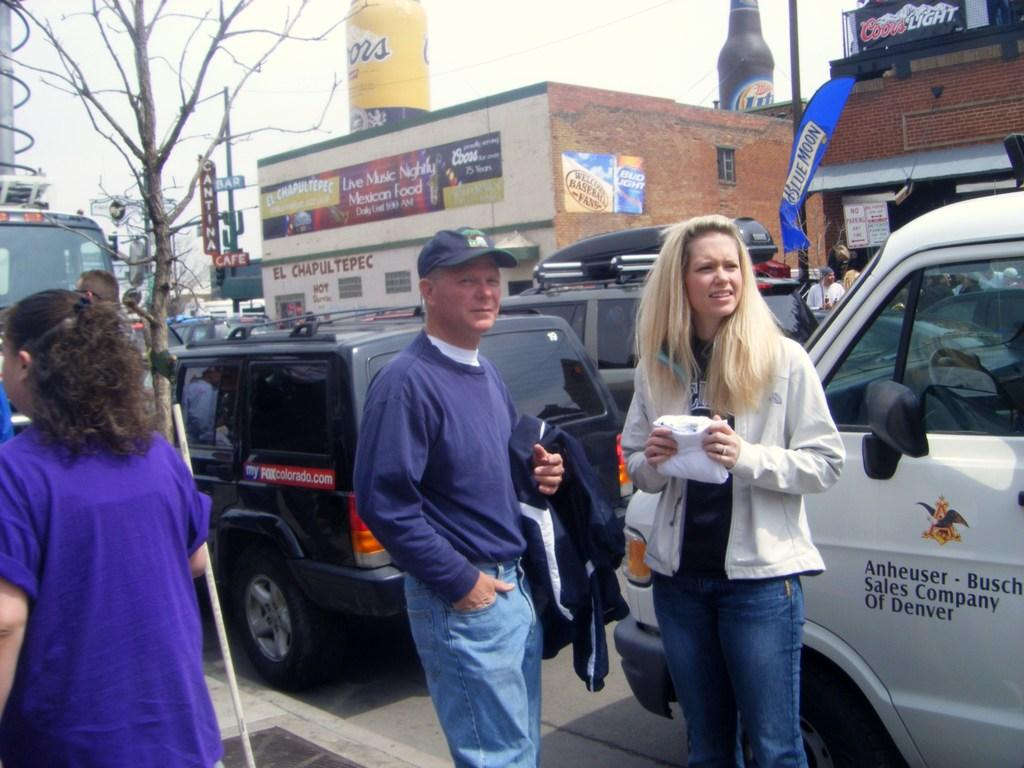<image>
Summarize the visual content of the image. A man and a woman are standing on the pavement in front of a white van that says Anheuser Busch Sales Company of Denver 